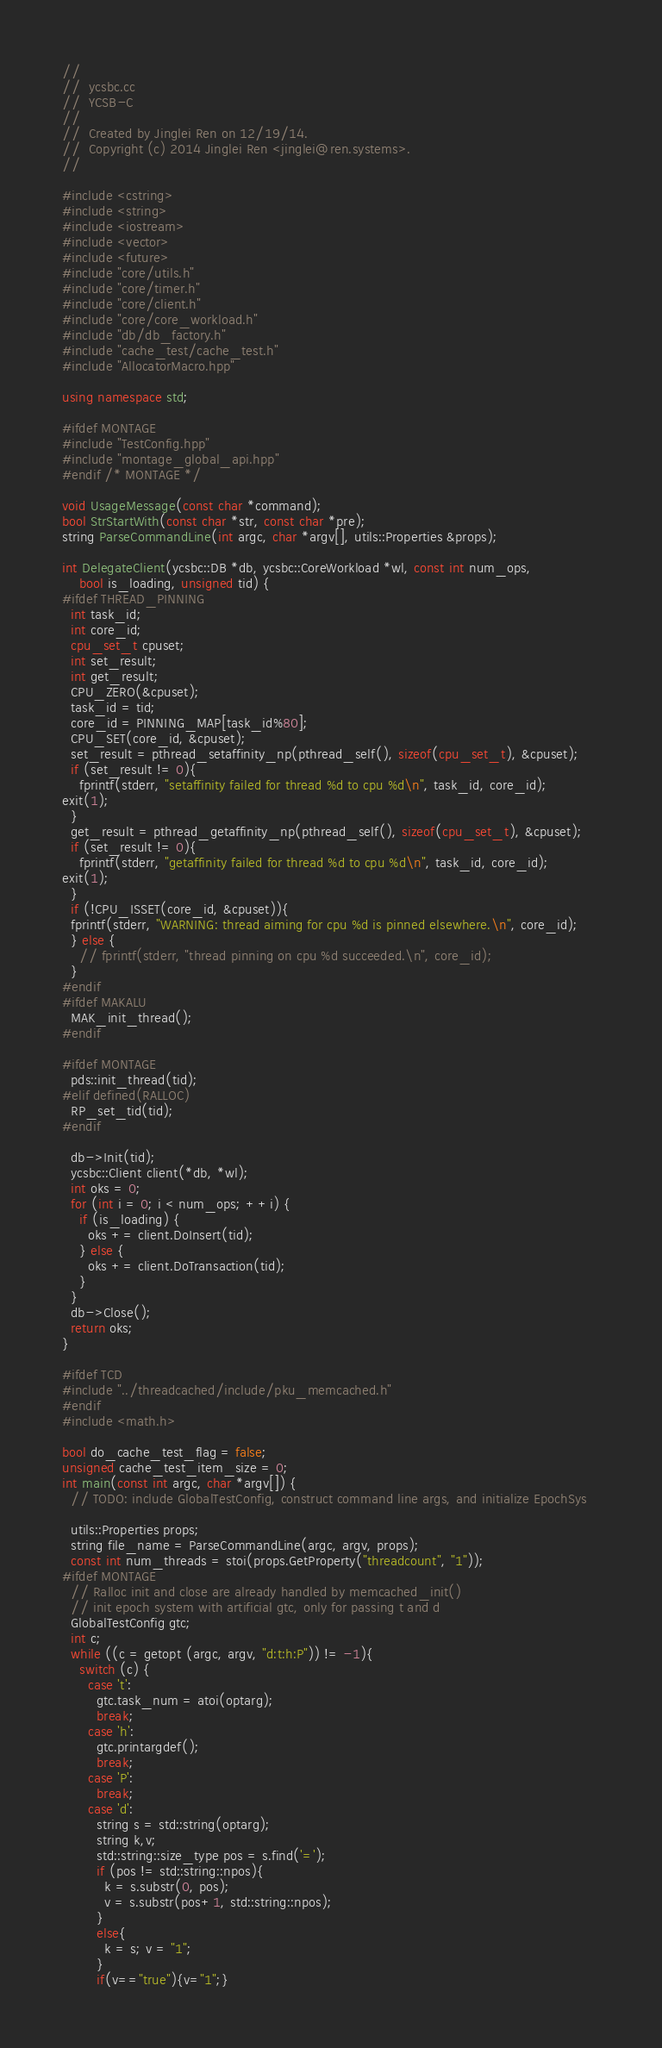Convert code to text. <code><loc_0><loc_0><loc_500><loc_500><_C++_>//
//  ycsbc.cc
//  YCSB-C
//
//  Created by Jinglei Ren on 12/19/14.
//  Copyright (c) 2014 Jinglei Ren <jinglei@ren.systems>.
//

#include <cstring>
#include <string>
#include <iostream>
#include <vector>
#include <future>
#include "core/utils.h"
#include "core/timer.h"
#include "core/client.h"
#include "core/core_workload.h"
#include "db/db_factory.h"
#include "cache_test/cache_test.h"
#include "AllocatorMacro.hpp"

using namespace std;

#ifdef MONTAGE
#include "TestConfig.hpp"
#include "montage_global_api.hpp"
#endif /* MONTAGE */

void UsageMessage(const char *command);
bool StrStartWith(const char *str, const char *pre);
string ParseCommandLine(int argc, char *argv[], utils::Properties &props);

int DelegateClient(ycsbc::DB *db, ycsbc::CoreWorkload *wl, const int num_ops,
    bool is_loading, unsigned tid) {
#ifdef THREAD_PINNING
  int task_id;
  int core_id;
  cpu_set_t cpuset;
  int set_result;
  int get_result;
  CPU_ZERO(&cpuset);
  task_id = tid;
  core_id = PINNING_MAP[task_id%80];
  CPU_SET(core_id, &cpuset);
  set_result = pthread_setaffinity_np(pthread_self(), sizeof(cpu_set_t), &cpuset);
  if (set_result != 0){
    fprintf(stderr, "setaffinity failed for thread %d to cpu %d\n", task_id, core_id);
exit(1);
  }
  get_result = pthread_getaffinity_np(pthread_self(), sizeof(cpu_set_t), &cpuset);
  if (set_result != 0){
    fprintf(stderr, "getaffinity failed for thread %d to cpu %d\n", task_id, core_id);
exit(1);
  }
  if (!CPU_ISSET(core_id, &cpuset)){
  fprintf(stderr, "WARNING: thread aiming for cpu %d is pinned elsewhere.\n", core_id);	 
  } else {
    // fprintf(stderr, "thread pinning on cpu %d succeeded.\n", core_id);
  }
#endif
#ifdef MAKALU
  MAK_init_thread();
#endif

#ifdef MONTAGE
  pds::init_thread(tid);
#elif defined(RALLOC)
  RP_set_tid(tid);
#endif

  db->Init(tid);
  ycsbc::Client client(*db, *wl);
  int oks = 0;
  for (int i = 0; i < num_ops; ++i) {
    if (is_loading) {
      oks += client.DoInsert(tid);
    } else {
      oks += client.DoTransaction(tid);
    }
  }
  db->Close();
  return oks;
}

#ifdef TCD
#include "../threadcached/include/pku_memcached.h"
#endif
#include <math.h>

bool do_cache_test_flag = false;
unsigned cache_test_item_size = 0; 
int main(const int argc, char *argv[]) {
  // TODO: include GlobalTestConfig, construct command line args, and initialize EpochSys
  
  utils::Properties props;
  string file_name = ParseCommandLine(argc, argv, props);
  const int num_threads = stoi(props.GetProperty("threadcount", "1"));
#ifdef MONTAGE
  // Ralloc init and close are already handled by memcached_init() 
  // init epoch system with artificial gtc, only for passing t and d
  GlobalTestConfig gtc;
  int c;
  while ((c = getopt (argc, argv, "d:t:h:P")) != -1){
    switch (c) {
      case 't':
        gtc.task_num = atoi(optarg);
        break;
      case 'h':
        gtc.printargdef();
        break;
      case 'P':
        break;
      case 'd':
        string s = std::string(optarg);
        string k,v;
        std::string::size_type pos = s.find('=');
        if (pos != std::string::npos){
          k = s.substr(0, pos);
          v = s.substr(pos+1, std::string::npos);
        }
        else{
          k = s; v = "1";
        }
        if(v=="true"){v="1";}</code> 